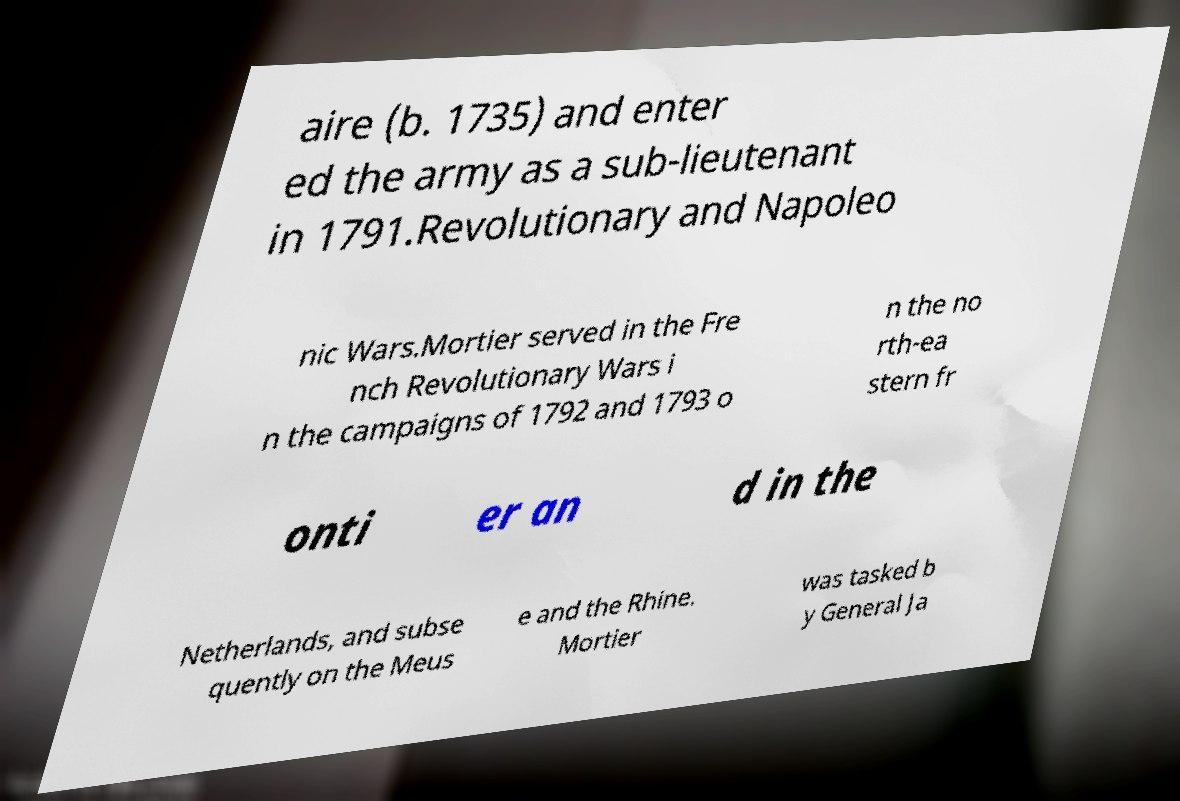For documentation purposes, I need the text within this image transcribed. Could you provide that? aire (b. 1735) and enter ed the army as a sub-lieutenant in 1791.Revolutionary and Napoleo nic Wars.Mortier served in the Fre nch Revolutionary Wars i n the campaigns of 1792 and 1793 o n the no rth-ea stern fr onti er an d in the Netherlands, and subse quently on the Meus e and the Rhine. Mortier was tasked b y General Ja 